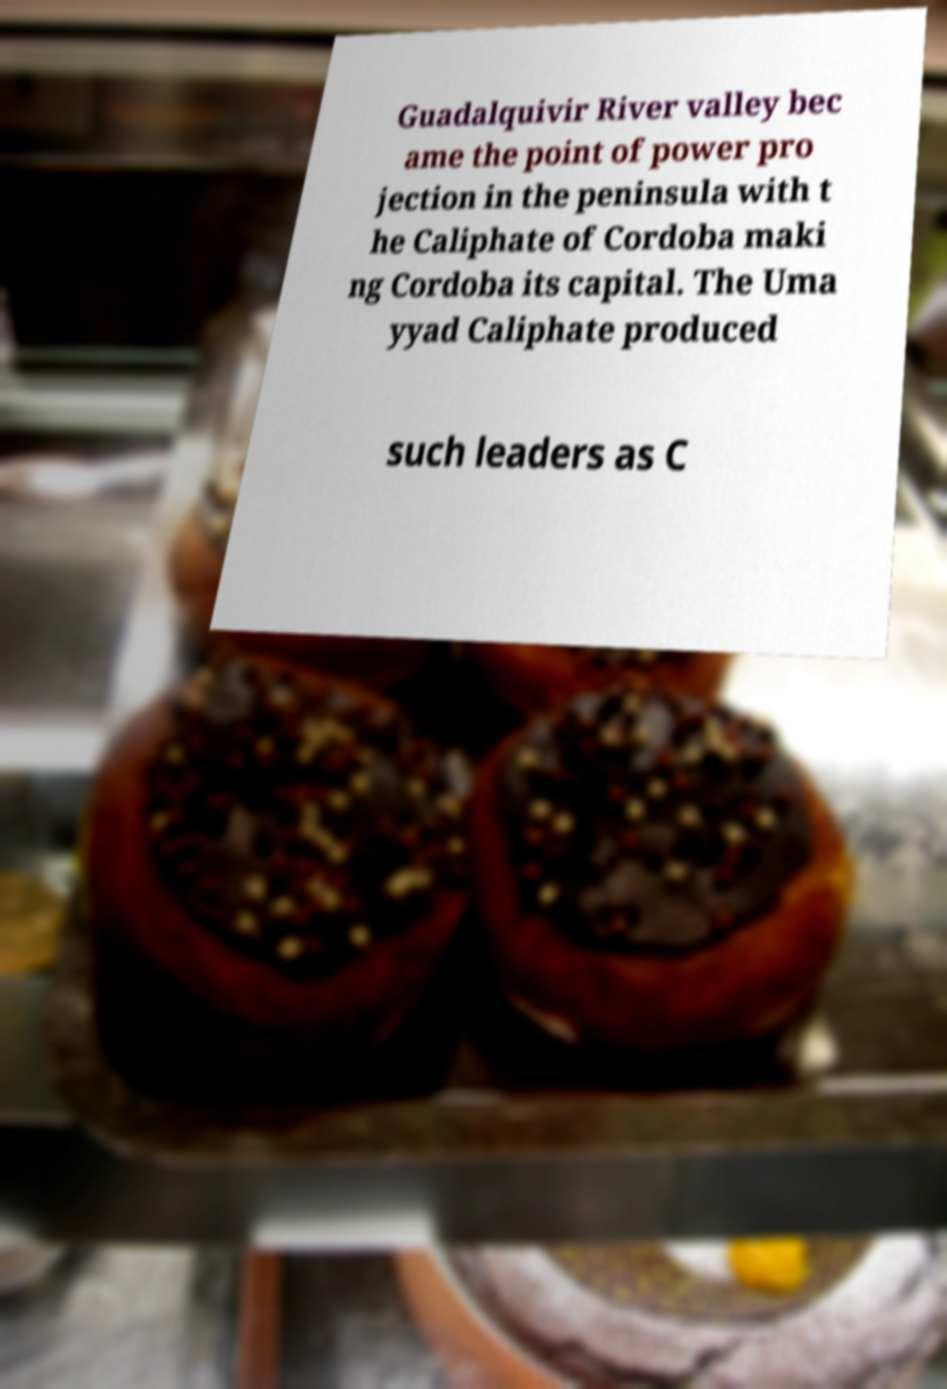Please read and relay the text visible in this image. What does it say? Guadalquivir River valley bec ame the point of power pro jection in the peninsula with t he Caliphate of Cordoba maki ng Cordoba its capital. The Uma yyad Caliphate produced such leaders as C 